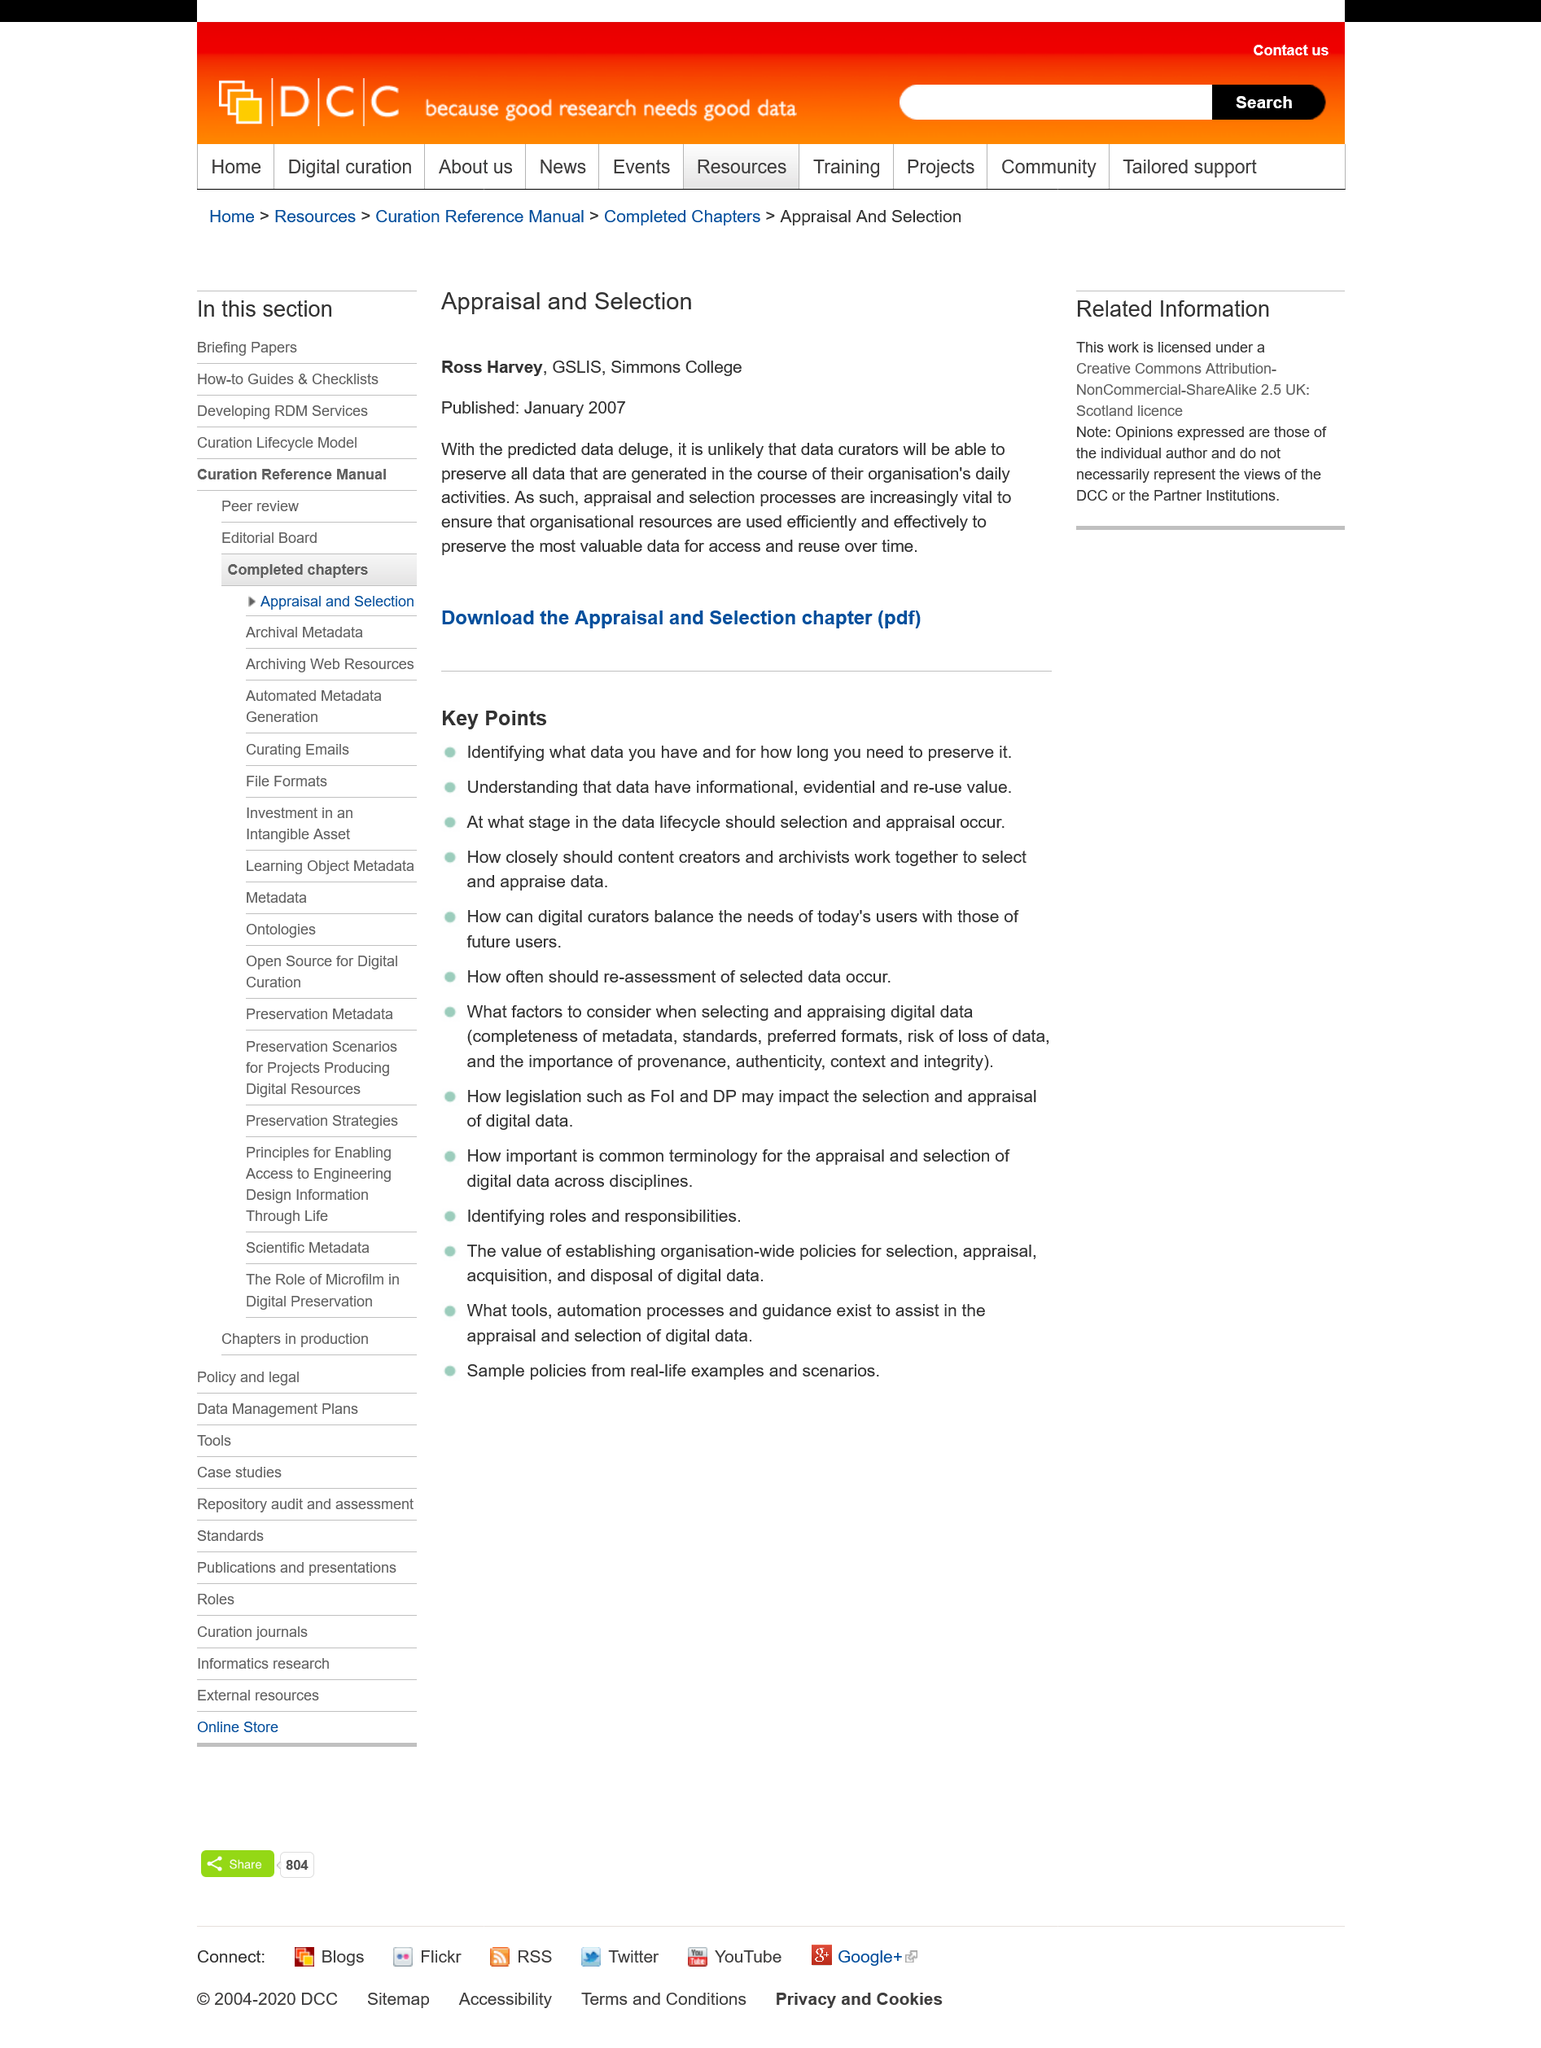Outline some significant characteristics in this image. The Appraisal and Selection article was published on January 2007. The appraisal and selection processes are crucial in ensuring the efficient use of organizational resources. It is not likely that the curators of the organization will be able to preserve all the data generated during their daily activities. 